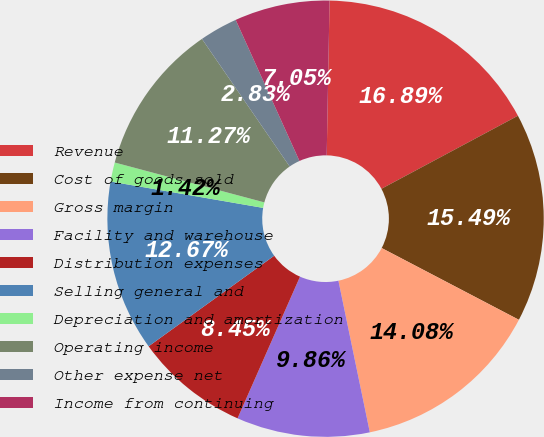Convert chart. <chart><loc_0><loc_0><loc_500><loc_500><pie_chart><fcel>Revenue<fcel>Cost of goods sold<fcel>Gross margin<fcel>Facility and warehouse<fcel>Distribution expenses<fcel>Selling general and<fcel>Depreciation and amortization<fcel>Operating income<fcel>Other expense net<fcel>Income from continuing<nl><fcel>16.89%<fcel>15.49%<fcel>14.08%<fcel>9.86%<fcel>8.45%<fcel>12.67%<fcel>1.42%<fcel>11.27%<fcel>2.83%<fcel>7.05%<nl></chart> 